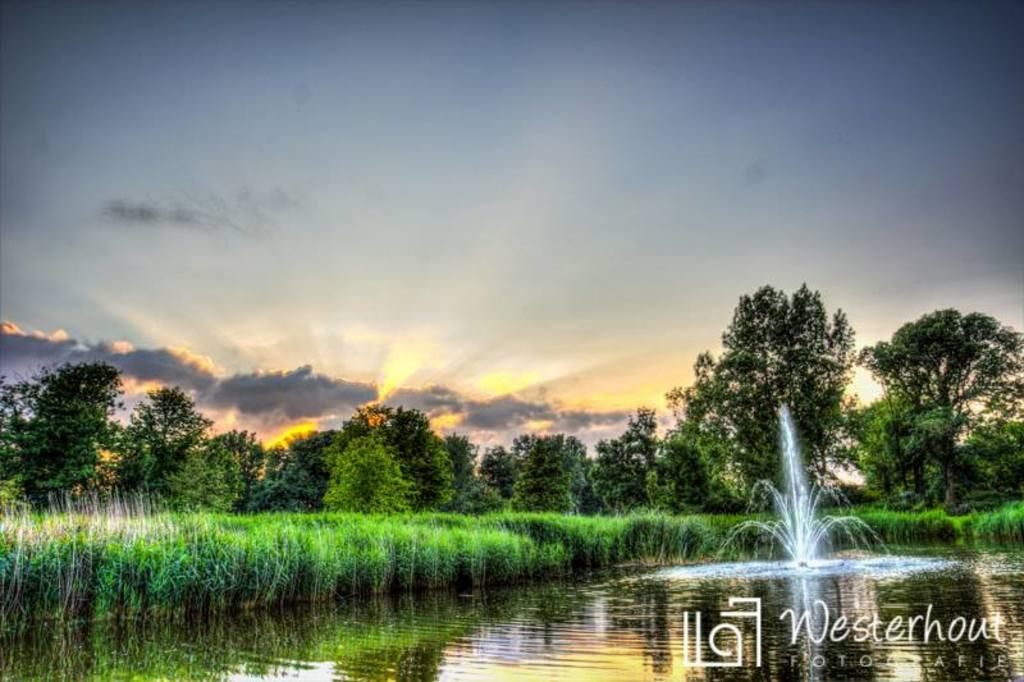What is the main feature in the image? There is a water fountain in the image. What other natural elements can be seen in the image? There are plants and trees in the image. What is visible in the background of the image? The sky is visible in the background of the image. Can you describe any additional details about the image? There is a watermark at the bottom of the image. What type of cherries are hanging from the water fountain in the image? There are no cherries present in the image; it features a water fountain, plants, trees, and a sky background. 